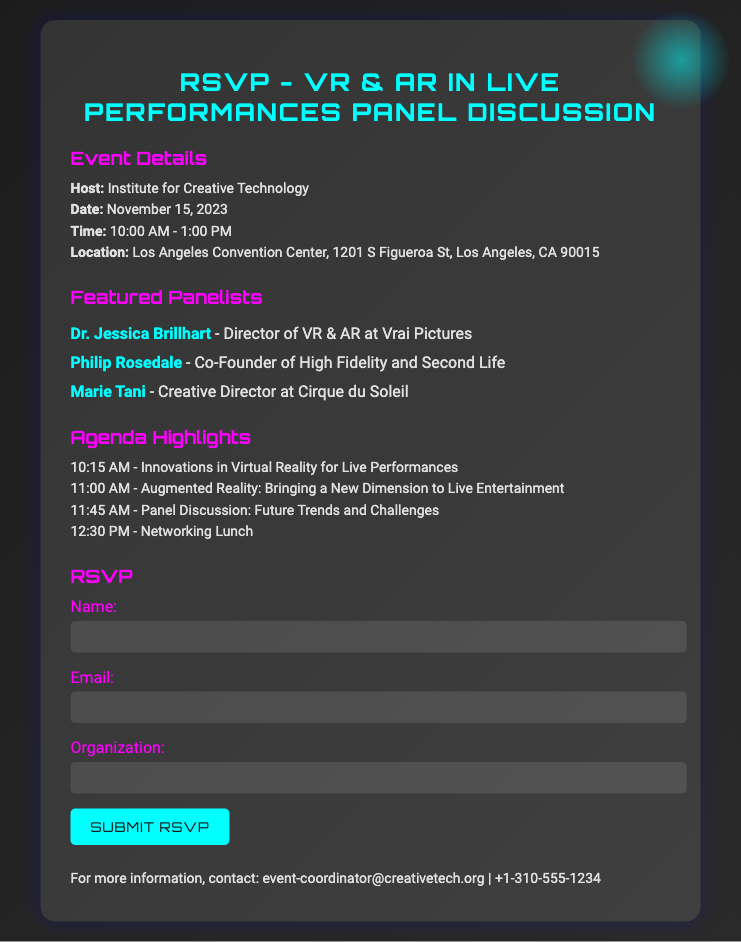What is the name of the host? The host of the event is specified in the document under the event details section.
Answer: Institute for Creative Technology When is the event scheduled? The date of the event is mentioned in the event details section.
Answer: November 15, 2023 What time does the panel discussion begin? The time of the event is found in the event details section.
Answer: 10:00 AM Who is a featured panelist? The names of the featured panelists are listed in the panelists section.
Answer: Dr. Jessica Brillhart What is one of the agenda highlights? The agenda highlights mentioned in the document provide an overview of the event schedule.
Answer: Innovations in Virtual Reality for Live Performances How many panelists are featured? The number of panelists can be determined by counting the listed names in the panelists section.
Answer: 3 What type of event is this document for? The purpose of the document, as indicated in the title, relates to the nature of the gathering.
Answer: Panel Discussion What is included in the RSVP form? The RSVP form includes fields for specific information that attendees must provide.
Answer: Name and Email 